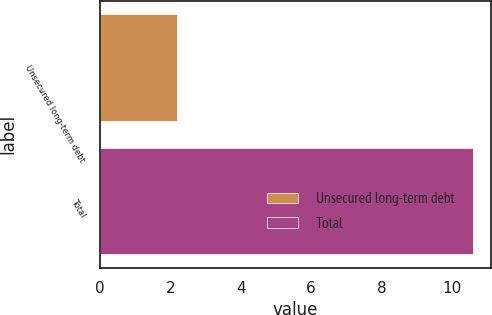Convert chart. <chart><loc_0><loc_0><loc_500><loc_500><bar_chart><fcel>Unsecured long-term debt<fcel>Total<nl><fcel>2.2<fcel>10.6<nl></chart> 